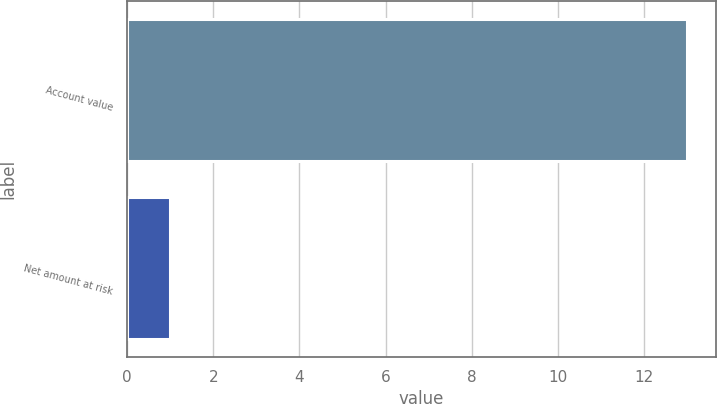Convert chart. <chart><loc_0><loc_0><loc_500><loc_500><bar_chart><fcel>Account value<fcel>Net amount at risk<nl><fcel>13<fcel>1<nl></chart> 